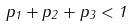Convert formula to latex. <formula><loc_0><loc_0><loc_500><loc_500>p _ { 1 } + p _ { 2 } + p _ { 3 } < 1</formula> 